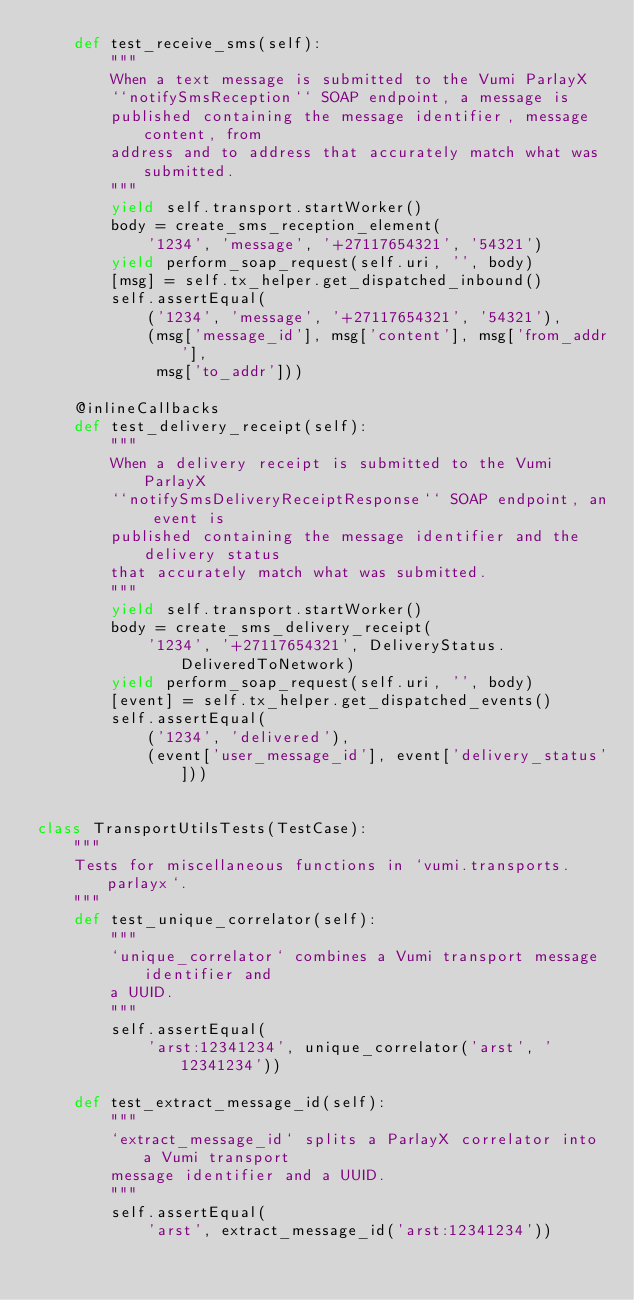<code> <loc_0><loc_0><loc_500><loc_500><_Python_>    def test_receive_sms(self):
        """
        When a text message is submitted to the Vumi ParlayX
        ``notifySmsReception`` SOAP endpoint, a message is
        published containing the message identifier, message content, from
        address and to address that accurately match what was submitted.
        """
        yield self.transport.startWorker()
        body = create_sms_reception_element(
            '1234', 'message', '+27117654321', '54321')
        yield perform_soap_request(self.uri, '', body)
        [msg] = self.tx_helper.get_dispatched_inbound()
        self.assertEqual(
            ('1234', 'message', '+27117654321', '54321'),
            (msg['message_id'], msg['content'], msg['from_addr'],
             msg['to_addr']))

    @inlineCallbacks
    def test_delivery_receipt(self):
        """
        When a delivery receipt is submitted to the Vumi ParlayX
        ``notifySmsDeliveryReceiptResponse`` SOAP endpoint, an event is
        published containing the message identifier and the delivery status
        that accurately match what was submitted.
        """
        yield self.transport.startWorker()
        body = create_sms_delivery_receipt(
            '1234', '+27117654321', DeliveryStatus.DeliveredToNetwork)
        yield perform_soap_request(self.uri, '', body)
        [event] = self.tx_helper.get_dispatched_events()
        self.assertEqual(
            ('1234', 'delivered'),
            (event['user_message_id'], event['delivery_status']))


class TransportUtilsTests(TestCase):
    """
    Tests for miscellaneous functions in `vumi.transports.parlayx`.
    """
    def test_unique_correlator(self):
        """
        `unique_correlator` combines a Vumi transport message identifier and
        a UUID.
        """
        self.assertEqual(
            'arst:12341234', unique_correlator('arst', '12341234'))

    def test_extract_message_id(self):
        """
        `extract_message_id` splits a ParlayX correlator into a Vumi transport
        message identifier and a UUID.
        """
        self.assertEqual(
            'arst', extract_message_id('arst:12341234'))
</code> 